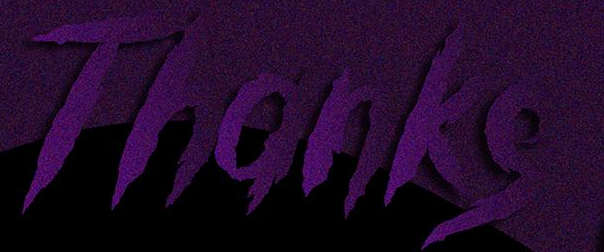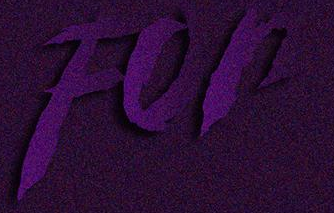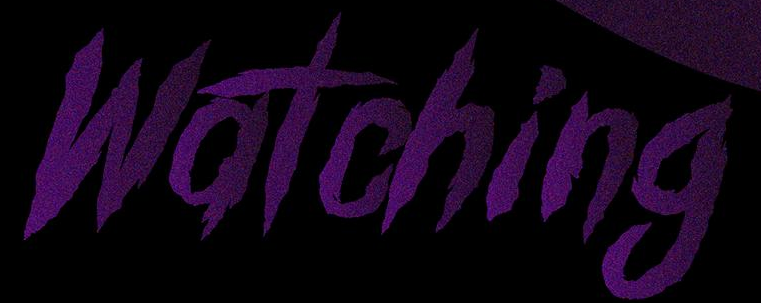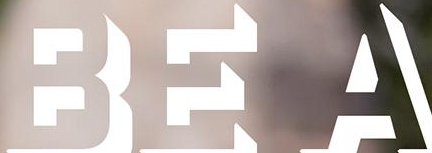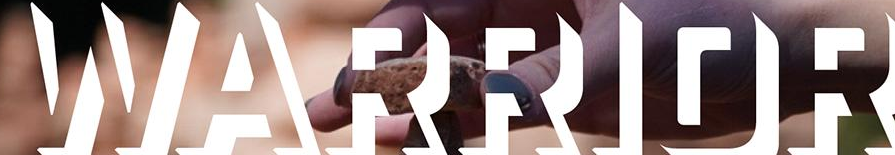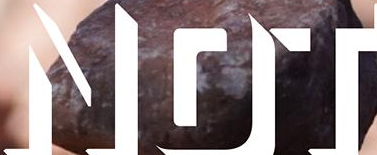Read the text from these images in sequence, separated by a semicolon. Thanks; For; Watching; BEA; WARRIOR; NOT 